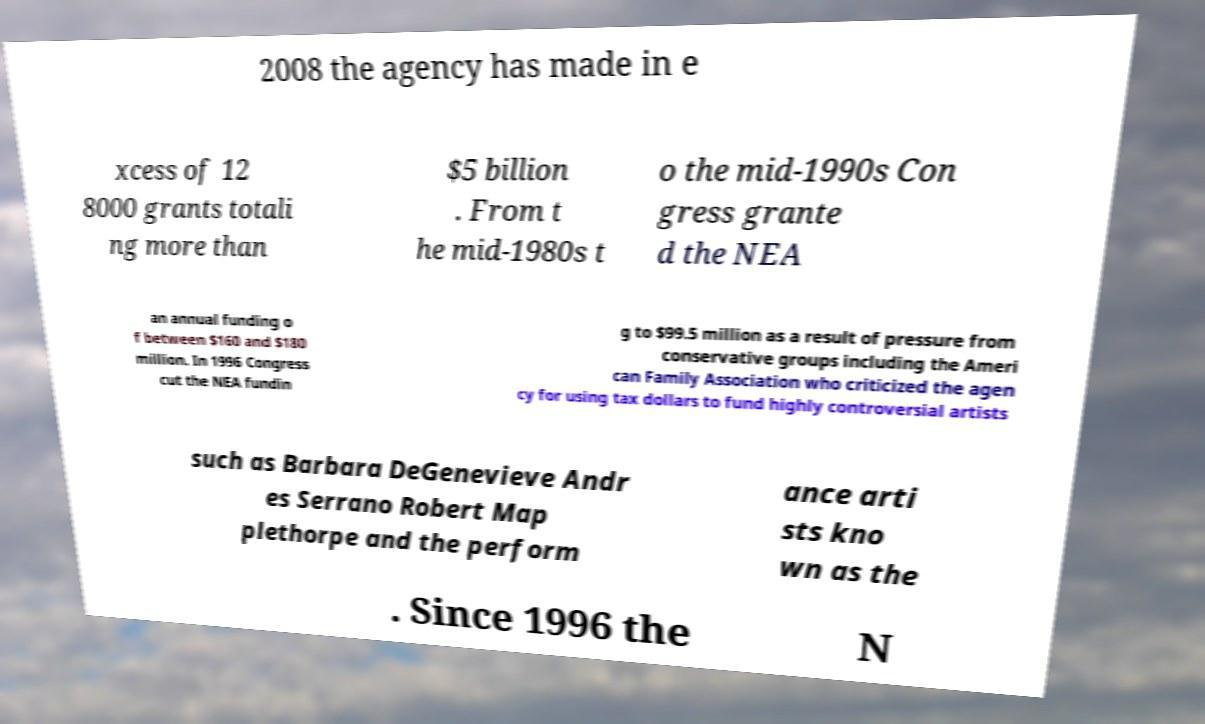I need the written content from this picture converted into text. Can you do that? 2008 the agency has made in e xcess of 12 8000 grants totali ng more than $5 billion . From t he mid-1980s t o the mid-1990s Con gress grante d the NEA an annual funding o f between $160 and $180 million. In 1996 Congress cut the NEA fundin g to $99.5 million as a result of pressure from conservative groups including the Ameri can Family Association who criticized the agen cy for using tax dollars to fund highly controversial artists such as Barbara DeGenevieve Andr es Serrano Robert Map plethorpe and the perform ance arti sts kno wn as the . Since 1996 the N 